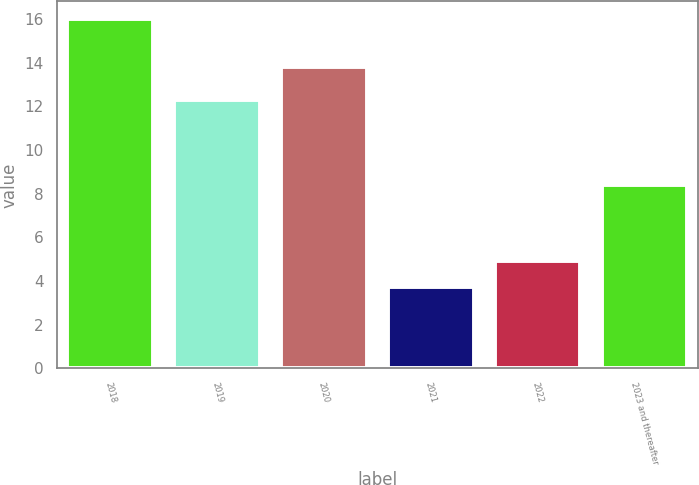Convert chart. <chart><loc_0><loc_0><loc_500><loc_500><bar_chart><fcel>2018<fcel>2019<fcel>2020<fcel>2021<fcel>2022<fcel>2023 and thereafter<nl><fcel>16<fcel>12.3<fcel>13.8<fcel>3.7<fcel>4.93<fcel>8.4<nl></chart> 